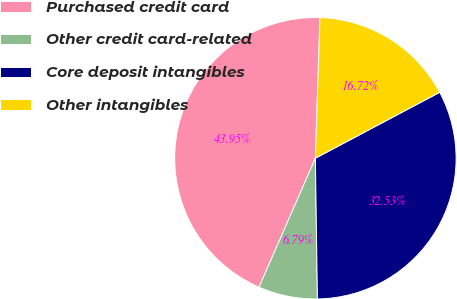<chart> <loc_0><loc_0><loc_500><loc_500><pie_chart><fcel>Purchased credit card<fcel>Other credit card-related<fcel>Core deposit intangibles<fcel>Other intangibles<nl><fcel>43.95%<fcel>6.79%<fcel>32.53%<fcel>16.72%<nl></chart> 